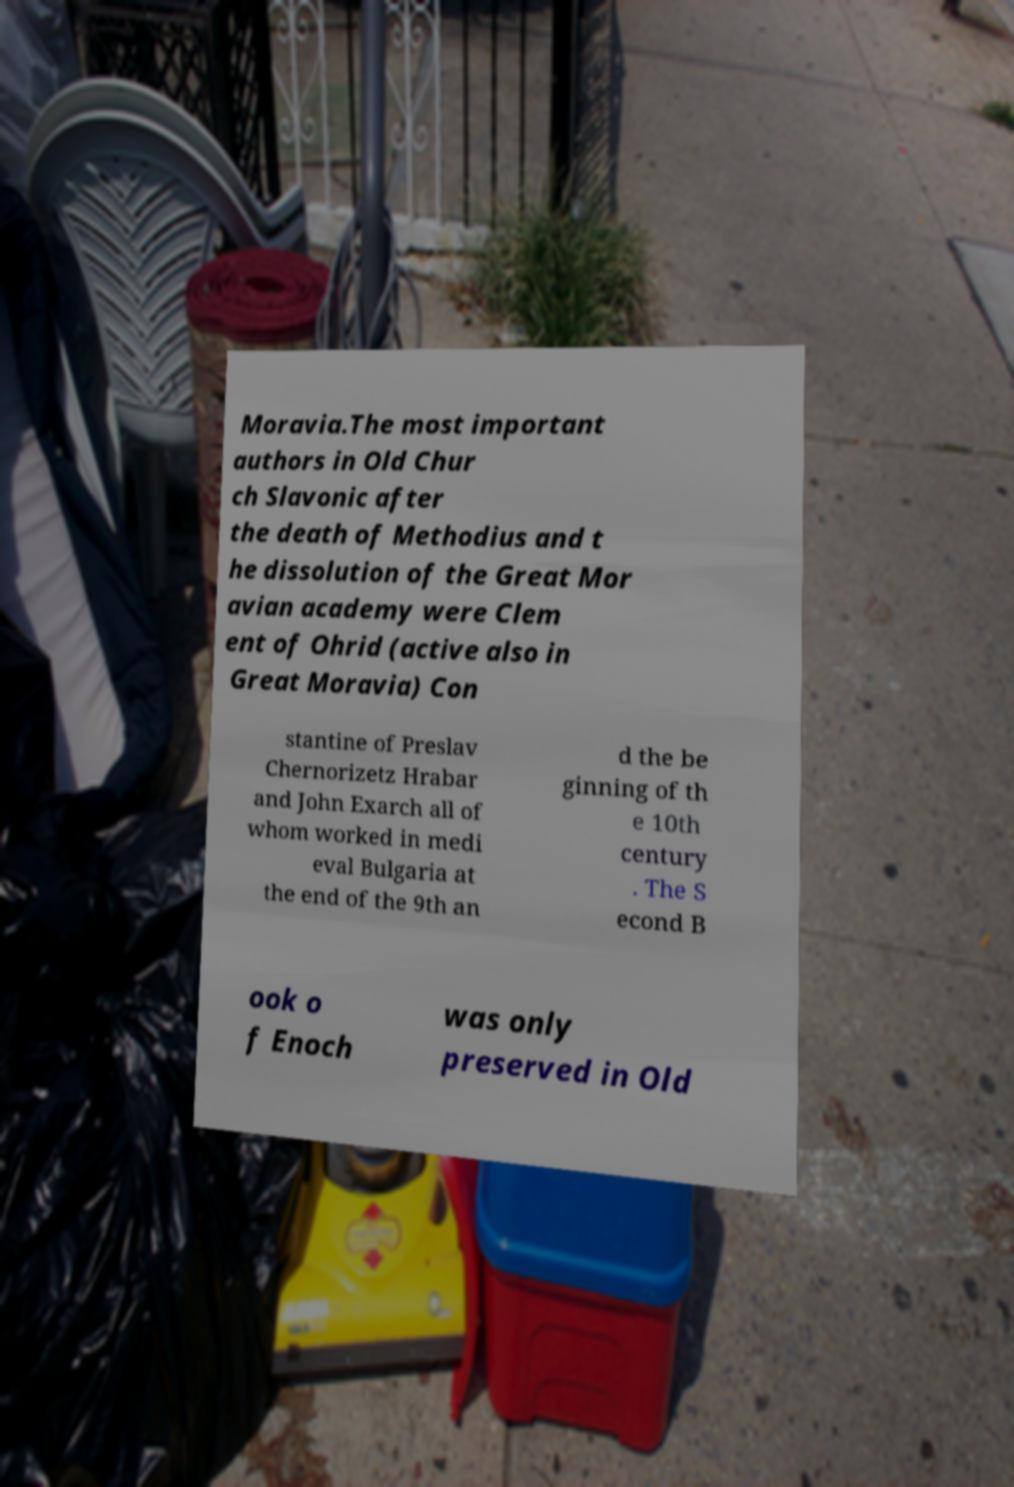Could you assist in decoding the text presented in this image and type it out clearly? Moravia.The most important authors in Old Chur ch Slavonic after the death of Methodius and t he dissolution of the Great Mor avian academy were Clem ent of Ohrid (active also in Great Moravia) Con stantine of Preslav Chernorizetz Hrabar and John Exarch all of whom worked in medi eval Bulgaria at the end of the 9th an d the be ginning of th e 10th century . The S econd B ook o f Enoch was only preserved in Old 